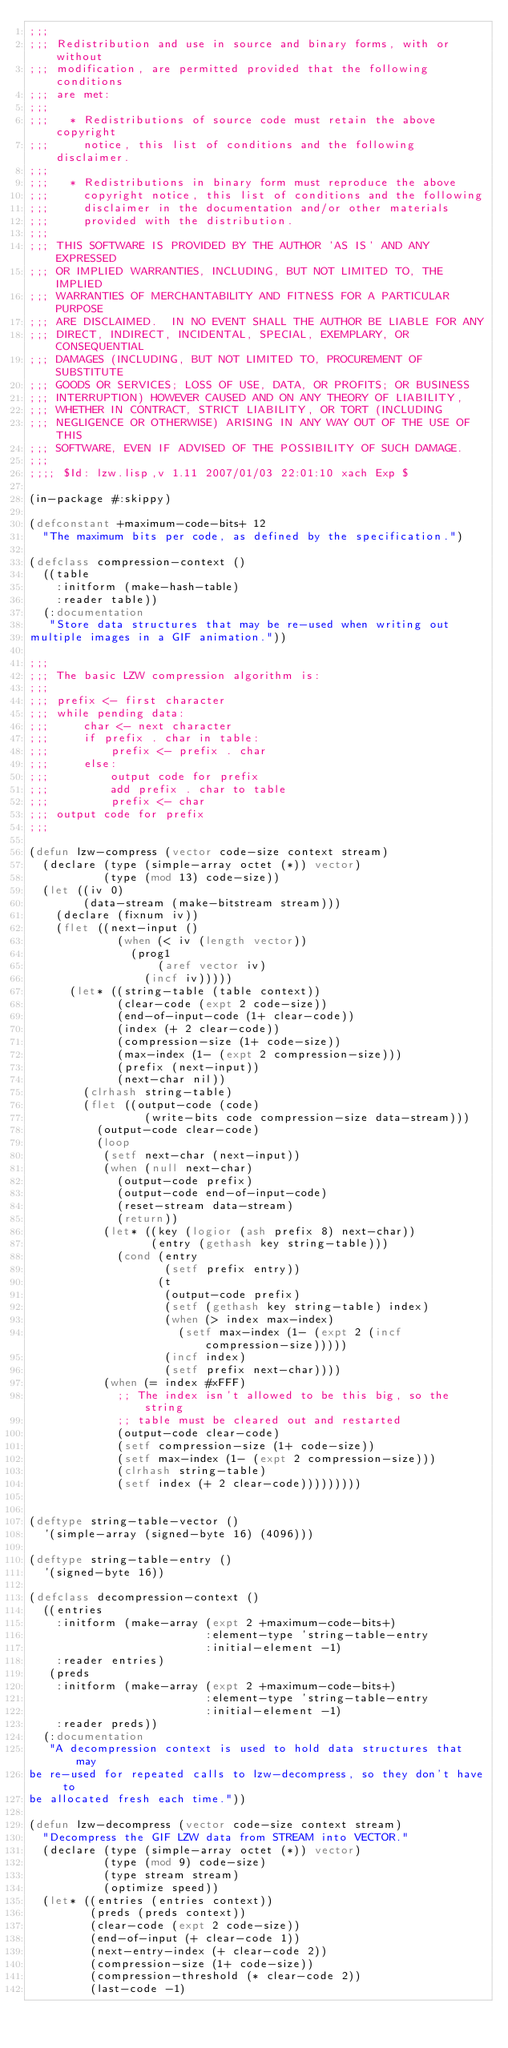Convert code to text. <code><loc_0><loc_0><loc_500><loc_500><_Lisp_>;;;
;;; Redistribution and use in source and binary forms, with or without
;;; modification, are permitted provided that the following conditions
;;; are met:
;;;
;;;   * Redistributions of source code must retain the above copyright
;;;     notice, this list of conditions and the following disclaimer.
;;;
;;;   * Redistributions in binary form must reproduce the above
;;;     copyright notice, this list of conditions and the following
;;;     disclaimer in the documentation and/or other materials
;;;     provided with the distribution.
;;;
;;; THIS SOFTWARE IS PROVIDED BY THE AUTHOR 'AS IS' AND ANY EXPRESSED
;;; OR IMPLIED WARRANTIES, INCLUDING, BUT NOT LIMITED TO, THE IMPLIED
;;; WARRANTIES OF MERCHANTABILITY AND FITNESS FOR A PARTICULAR PURPOSE
;;; ARE DISCLAIMED.  IN NO EVENT SHALL THE AUTHOR BE LIABLE FOR ANY
;;; DIRECT, INDIRECT, INCIDENTAL, SPECIAL, EXEMPLARY, OR CONSEQUENTIAL
;;; DAMAGES (INCLUDING, BUT NOT LIMITED TO, PROCUREMENT OF SUBSTITUTE
;;; GOODS OR SERVICES; LOSS OF USE, DATA, OR PROFITS; OR BUSINESS
;;; INTERRUPTION) HOWEVER CAUSED AND ON ANY THEORY OF LIABILITY,
;;; WHETHER IN CONTRACT, STRICT LIABILITY, OR TORT (INCLUDING
;;; NEGLIGENCE OR OTHERWISE) ARISING IN ANY WAY OUT OF THE USE OF THIS
;;; SOFTWARE, EVEN IF ADVISED OF THE POSSIBILITY OF SUCH DAMAGE.
;;;
;;;; $Id: lzw.lisp,v 1.11 2007/01/03 22:01:10 xach Exp $

(in-package #:skippy)

(defconstant +maximum-code-bits+ 12
  "The maximum bits per code, as defined by the specification.")

(defclass compression-context ()
  ((table
    :initform (make-hash-table)
    :reader table))
  (:documentation
   "Store data structures that may be re-used when writing out
multiple images in a GIF animation."))

;;;
;;; The basic LZW compression algorithm is:
;;;
;;; prefix <- first character
;;; while pending data:
;;;     char <- next character
;;;     if prefix . char in table:
;;;         prefix <- prefix . char
;;;     else:
;;;         output code for prefix
;;;         add prefix . char to table
;;;         prefix <- char
;;; output code for prefix
;;;

(defun lzw-compress (vector code-size context stream)
  (declare (type (simple-array octet (*)) vector)
           (type (mod 13) code-size))
  (let ((iv 0)
        (data-stream (make-bitstream stream)))
    (declare (fixnum iv))
    (flet ((next-input ()
             (when (< iv (length vector))
               (prog1
                   (aref vector iv)
                 (incf iv)))))
      (let* ((string-table (table context))
             (clear-code (expt 2 code-size))
             (end-of-input-code (1+ clear-code))
             (index (+ 2 clear-code))
             (compression-size (1+ code-size))
             (max-index (1- (expt 2 compression-size)))
             (prefix (next-input))
             (next-char nil))
        (clrhash string-table)
        (flet ((output-code (code)
                 (write-bits code compression-size data-stream)))
          (output-code clear-code)
          (loop
           (setf next-char (next-input))
           (when (null next-char)
             (output-code prefix)
             (output-code end-of-input-code)
             (reset-stream data-stream)
             (return))
           (let* ((key (logior (ash prefix 8) next-char))
                  (entry (gethash key string-table)))
             (cond (entry
                    (setf prefix entry))
                   (t
                    (output-code prefix)
                    (setf (gethash key string-table) index)
                    (when (> index max-index)
                      (setf max-index (1- (expt 2 (incf compression-size)))))
                    (incf index)
                    (setf prefix next-char))))
           (when (= index #xFFF)
             ;; The index isn't allowed to be this big, so the string
             ;; table must be cleared out and restarted
             (output-code clear-code)
             (setf compression-size (1+ code-size))
             (setf max-index (1- (expt 2 compression-size)))
             (clrhash string-table)
             (setf index (+ 2 clear-code)))))))))


(deftype string-table-vector ()
  '(simple-array (signed-byte 16) (4096)))

(deftype string-table-entry ()
  '(signed-byte 16))

(defclass decompression-context ()
  ((entries
    :initform (make-array (expt 2 +maximum-code-bits+)
                          :element-type 'string-table-entry
                          :initial-element -1)
    :reader entries)
   (preds
    :initform (make-array (expt 2 +maximum-code-bits+)
                          :element-type 'string-table-entry
                          :initial-element -1)
    :reader preds))
  (:documentation
   "A decompression context is used to hold data structures that may
be re-used for repeated calls to lzw-decompress, so they don't have to
be allocated fresh each time."))

(defun lzw-decompress (vector code-size context stream)
  "Decompress the GIF LZW data from STREAM into VECTOR."
  (declare (type (simple-array octet (*)) vector)
           (type (mod 9) code-size)
           (type stream stream)
           (optimize speed))
  (let* ((entries (entries context))
         (preds (preds context))
         (clear-code (expt 2 code-size))
         (end-of-input (+ clear-code 1))
         (next-entry-index (+ clear-code 2))
         (compression-size (1+ code-size))
         (compression-threshold (* clear-code 2))
         (last-code -1)</code> 